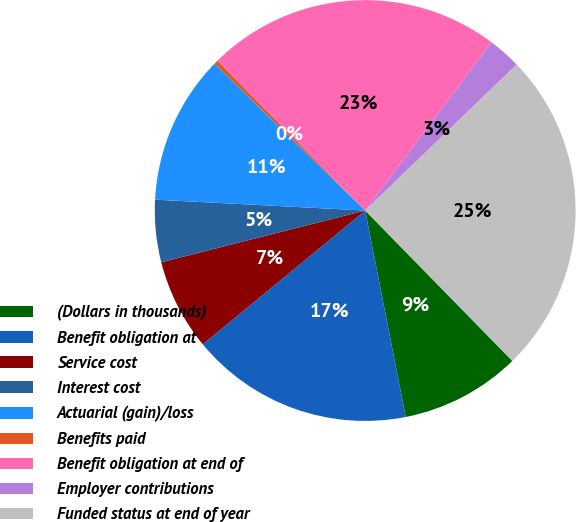<chart> <loc_0><loc_0><loc_500><loc_500><pie_chart><fcel>(Dollars in thousands)<fcel>Benefit obligation at<fcel>Service cost<fcel>Interest cost<fcel>Actuarial (gain)/loss<fcel>Benefits paid<fcel>Benefit obligation at end of<fcel>Employer contributions<fcel>Funded status at end of year<nl><fcel>9.24%<fcel>17.12%<fcel>7.01%<fcel>4.78%<fcel>11.48%<fcel>0.31%<fcel>22.64%<fcel>2.54%<fcel>24.88%<nl></chart> 